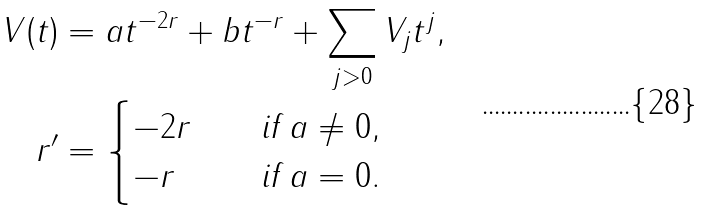Convert formula to latex. <formula><loc_0><loc_0><loc_500><loc_500>V ( t ) & = a t ^ { - 2 r } + b t ^ { - r } + \sum _ { j > 0 } V _ { j } t ^ { j } , \\ r ^ { \prime } & = \begin{cases} - 2 r \quad & \text {if } a \ne 0 , \\ - r \quad & \text {if } a = 0 . \\ \end{cases}</formula> 